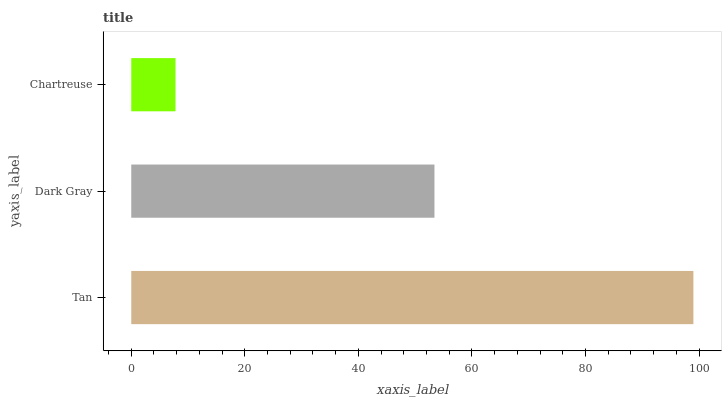Is Chartreuse the minimum?
Answer yes or no. Yes. Is Tan the maximum?
Answer yes or no. Yes. Is Dark Gray the minimum?
Answer yes or no. No. Is Dark Gray the maximum?
Answer yes or no. No. Is Tan greater than Dark Gray?
Answer yes or no. Yes. Is Dark Gray less than Tan?
Answer yes or no. Yes. Is Dark Gray greater than Tan?
Answer yes or no. No. Is Tan less than Dark Gray?
Answer yes or no. No. Is Dark Gray the high median?
Answer yes or no. Yes. Is Dark Gray the low median?
Answer yes or no. Yes. Is Chartreuse the high median?
Answer yes or no. No. Is Tan the low median?
Answer yes or no. No. 